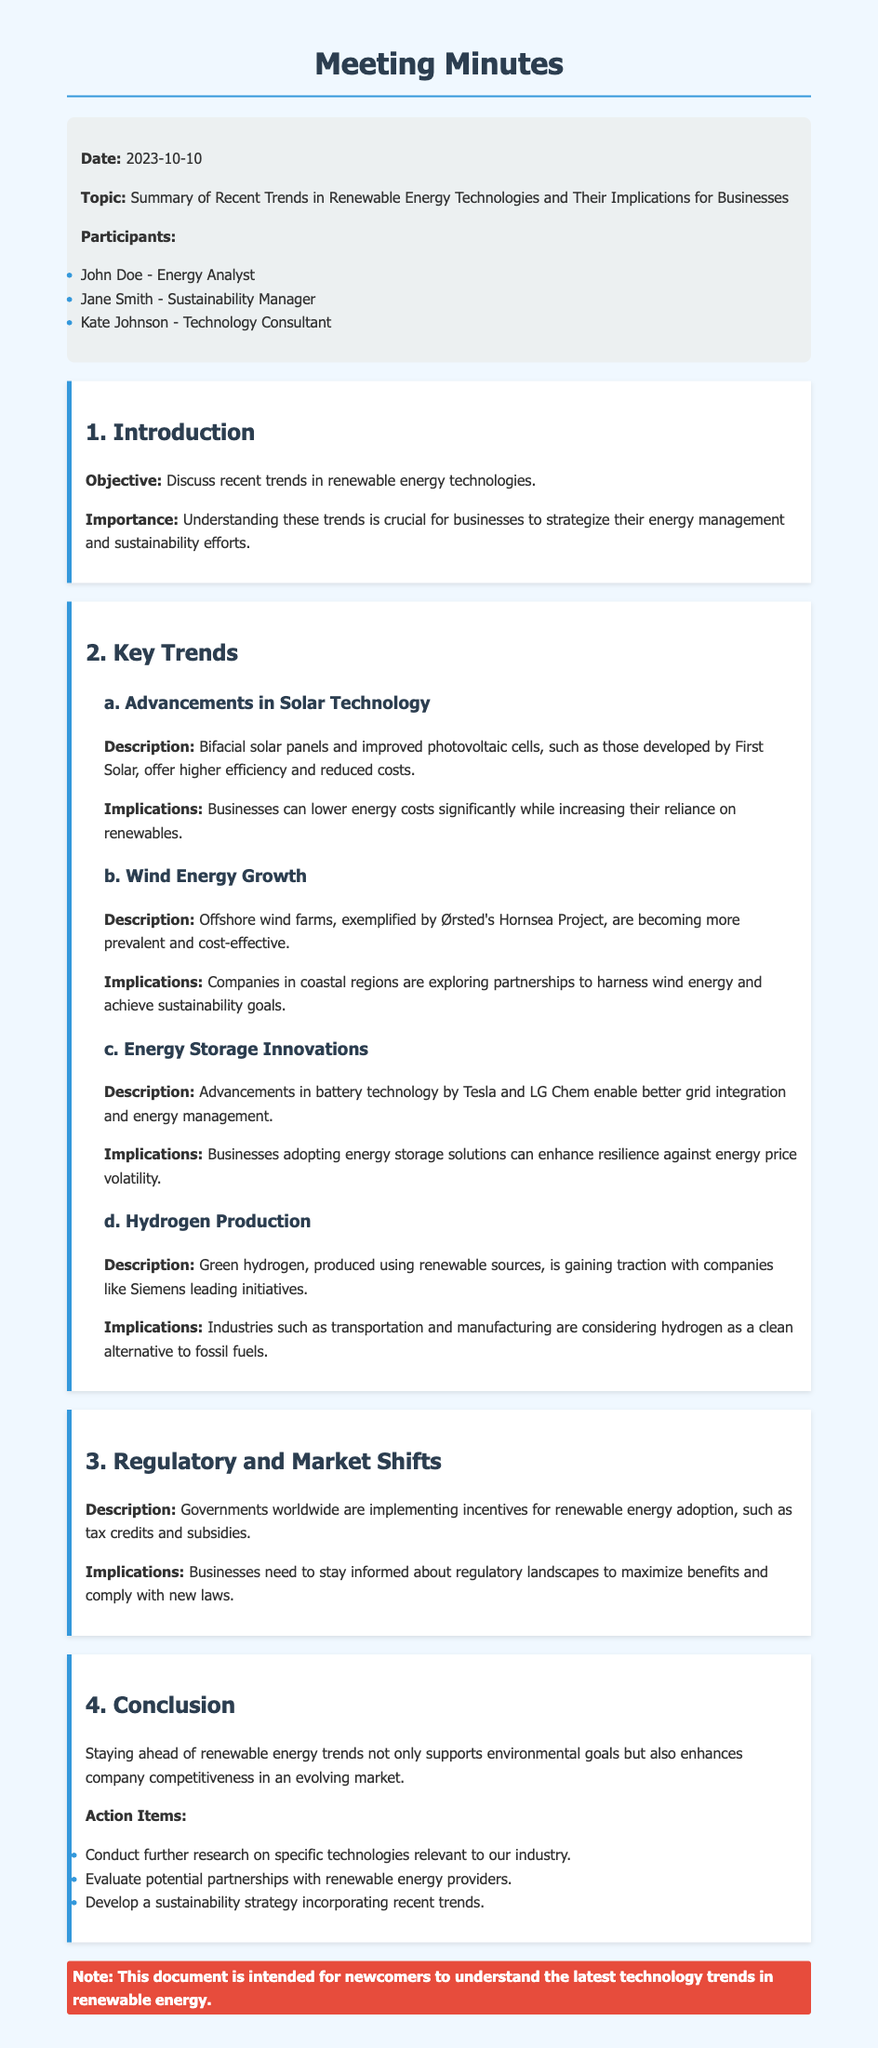What is the date of the meeting? The date of the meeting is mentioned in the header of the document.
Answer: 2023-10-10 Who is the Energy Analyst? The participants of the meeting are listed in the header section.
Answer: John Doe What are the recent advancements in solar technology? The document states specific advancements under the key trends section.
Answer: Bifacial solar panels and improved photovoltaic cells What is a key implication of wind energy growth for businesses? The implications of wind energy growth are described in the subsection discussing it.
Answer: Explore partnerships How is green hydrogen produced? The document provides information about the method of hydrogen production in the relevant subsection.
Answer: Using renewable sources What should businesses stay informed about? The document discusses the importance of regulatory knowledge in the market shifts section.
Answer: Regulatory landscapes What action item involves evaluating renewable energy providers? The action items are listed at the end of the conclusion section.
Answer: Evaluate potential partnerships What is the objective of the meeting? The objective is clearly stated in the introduction of the minutes.
Answer: Discuss recent trends in renewable energy technologies What is the main topic of the meeting? The topic is specifically mentioned in the header section of the document.
Answer: Summary of Recent Trends in Renewable Energy Technologies and Their Implications for Businesses 